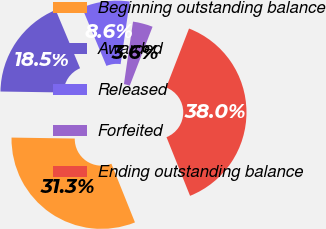Convert chart. <chart><loc_0><loc_0><loc_500><loc_500><pie_chart><fcel>Beginning outstanding balance<fcel>Awarded<fcel>Released<fcel>Forfeited<fcel>Ending outstanding balance<nl><fcel>31.32%<fcel>18.45%<fcel>8.61%<fcel>3.58%<fcel>38.04%<nl></chart> 